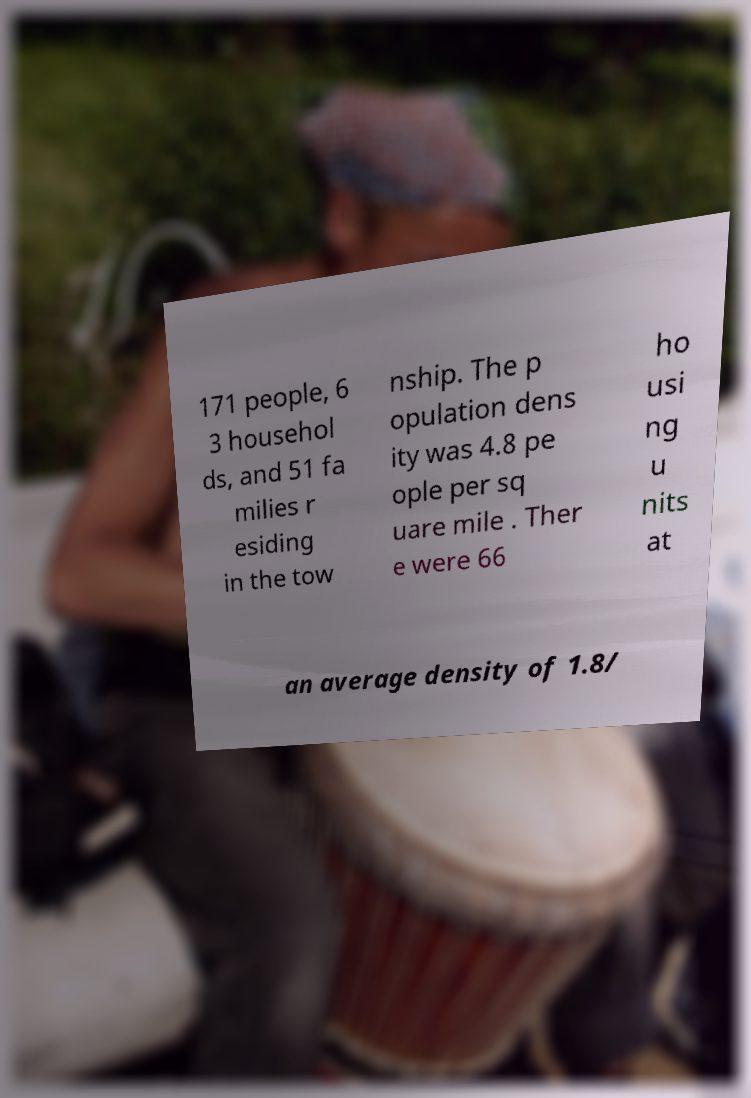There's text embedded in this image that I need extracted. Can you transcribe it verbatim? 171 people, 6 3 househol ds, and 51 fa milies r esiding in the tow nship. The p opulation dens ity was 4.8 pe ople per sq uare mile . Ther e were 66 ho usi ng u nits at an average density of 1.8/ 